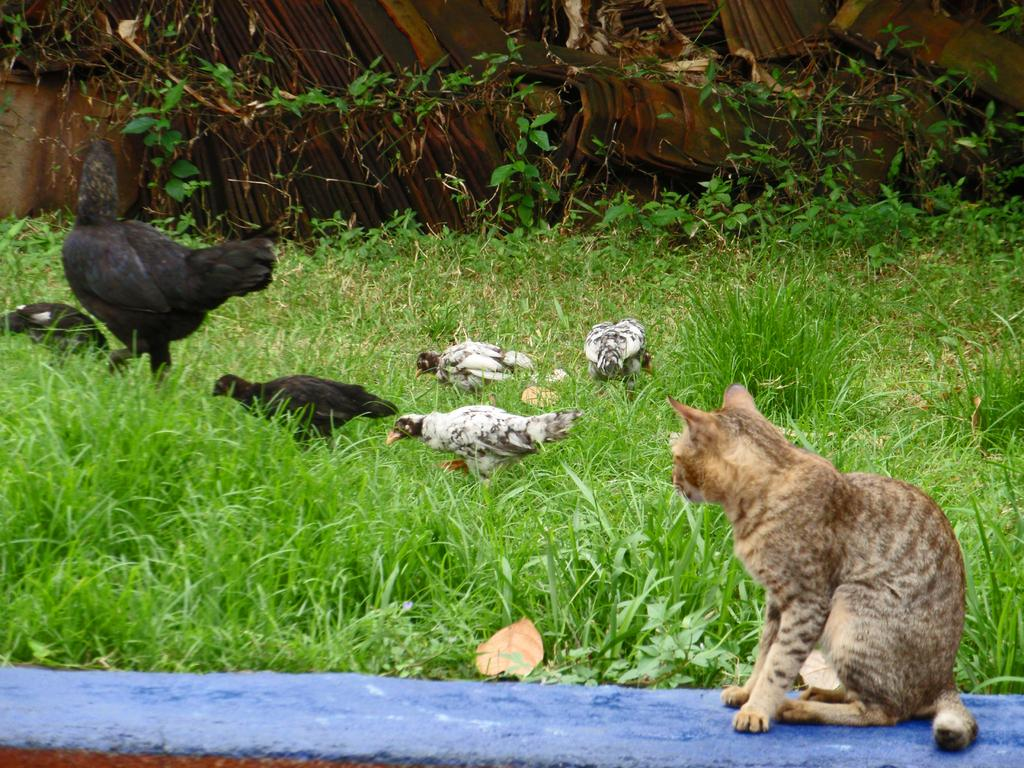What animal can be seen sitting on a wall in the image? There is there a cat sitting on a wall in the image? What type of vegetation is visible in the image? There is grass visible in the image, and there are also plants, although their exact nature is uncertain. What type of birds are present in the image? There is a flock of hens in the image. What type of pies can be seen cooling on the street in the image? There is no mention of pies or a street in the image; it features a cat sitting on a wall, grass, a flock of hens, and plants. 